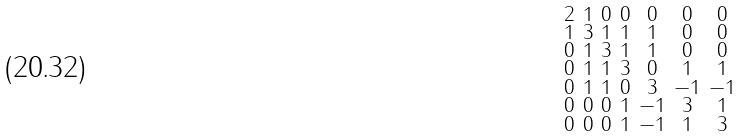Convert formula to latex. <formula><loc_0><loc_0><loc_500><loc_500>\begin{smallmatrix} 2 & 1 & 0 & 0 & 0 & 0 & 0 \\ 1 & 3 & 1 & 1 & 1 & 0 & 0 \\ 0 & 1 & 3 & 1 & 1 & 0 & 0 \\ 0 & 1 & 1 & 3 & 0 & 1 & 1 \\ 0 & 1 & 1 & 0 & 3 & - 1 & - 1 \\ 0 & 0 & 0 & 1 & - 1 & 3 & 1 \\ 0 & 0 & 0 & 1 & - 1 & 1 & 3 \end{smallmatrix}</formula> 